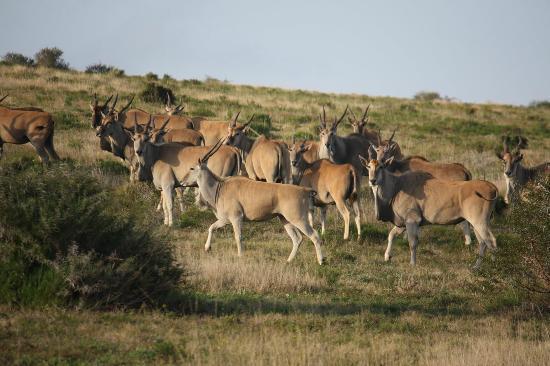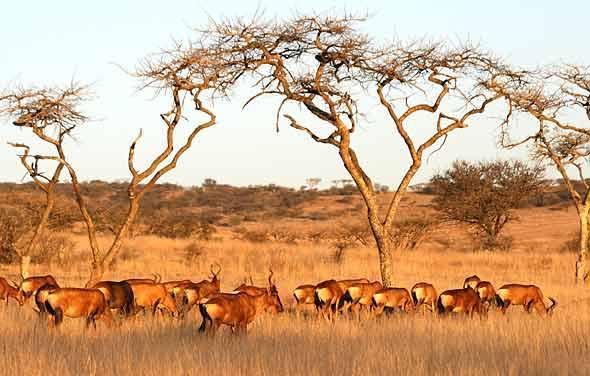The first image is the image on the left, the second image is the image on the right. For the images displayed, is the sentence "There are less than 5 animals." factually correct? Answer yes or no. No. The first image is the image on the left, the second image is the image on the right. Considering the images on both sides, is "There is one horned mammal sitting in the left image, and multiple standing in the right." valid? Answer yes or no. No. 